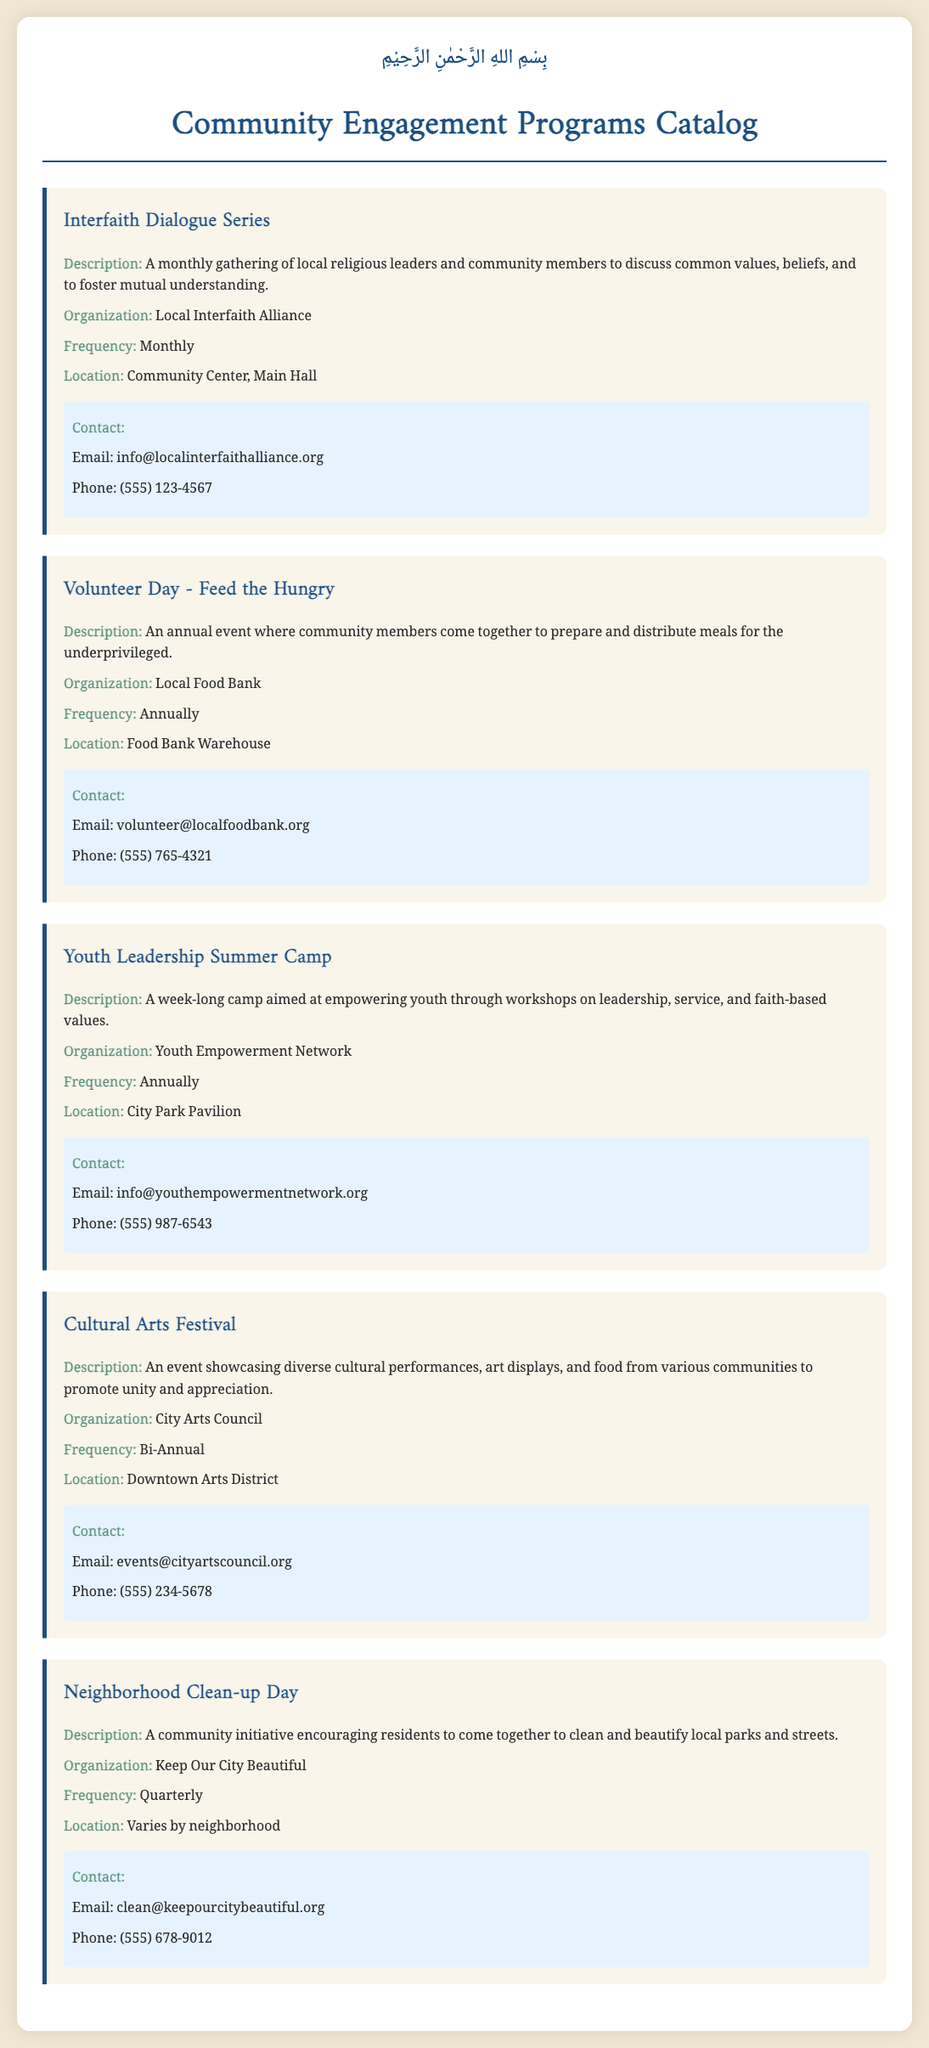What is the title of the first program? The title of the first program listed in the document is "Interfaith Dialogue Series."
Answer: Interfaith Dialogue Series How often does the "Volunteer Day - Feed the Hungry" occur? The document states that the "Volunteer Day - Feed the Hungry" occurs annually.
Answer: Annually What organization is responsible for the "Youth Leadership Summer Camp"? According to the document, the organization responsible for this program is the "Youth Empowerment Network."
Answer: Youth Empowerment Network Where is the "Cultural Arts Festival" located? The document specifies that the "Cultural Arts Festival" is held in the "Downtown Arts District."
Answer: Downtown Arts District What is the contact email for the "Neighborhood Clean-up Day"? The contact email provided in the document for this program is "clean@keepourcitybeautiful.org."
Answer: clean@keepourcitybeautiful.org Which program promotes interfaith discussions? The document indicates that the program focused on interfaith discussions is the "Interfaith Dialogue Series."
Answer: Interfaith Dialogue Series How many times a year is the "Neighborhood Clean-up Day" held? The document indicates that the "Neighborhood Clean-up Day" is held quarterly, which is four times a year.
Answer: Quarterly What is the main focus of the "Volunteer Day - Feed the Hungry"? The main focus of this program, as per the document, is to prepare and distribute meals for the underprivileged.
Answer: Prepare and distribute meals What is the theme of the "Cultural Arts Festival"? The document describes the theme of this festival as showcasing diverse cultural performances and art displays.
Answer: Diverse cultural performances and art displays 